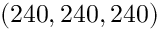<formula> <loc_0><loc_0><loc_500><loc_500>( 2 4 0 , 2 4 0 , 2 4 0 )</formula> 